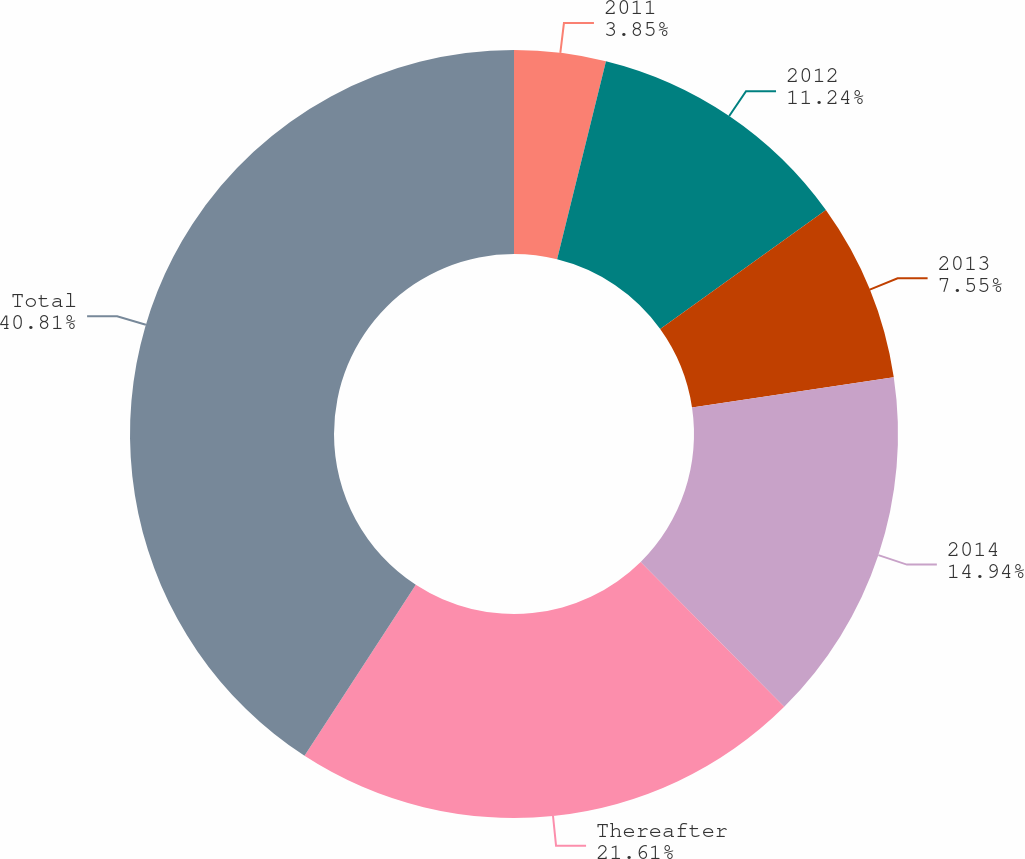<chart> <loc_0><loc_0><loc_500><loc_500><pie_chart><fcel>2011<fcel>2012<fcel>2013<fcel>2014<fcel>Thereafter<fcel>Total<nl><fcel>3.85%<fcel>11.24%<fcel>7.55%<fcel>14.94%<fcel>21.61%<fcel>40.82%<nl></chart> 